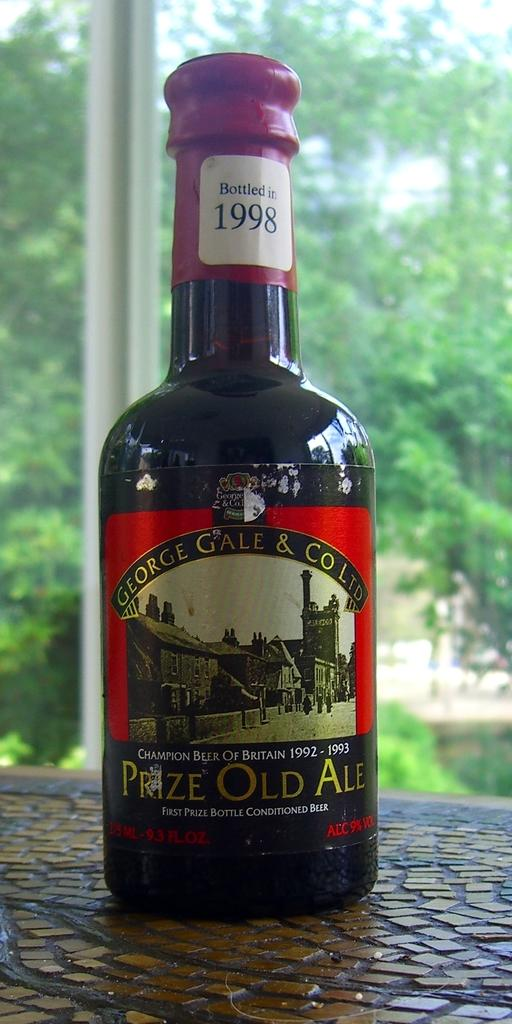<image>
Relay a brief, clear account of the picture shown. A sealed red and black bottle of Prize Old Ale with trees in the distance. 